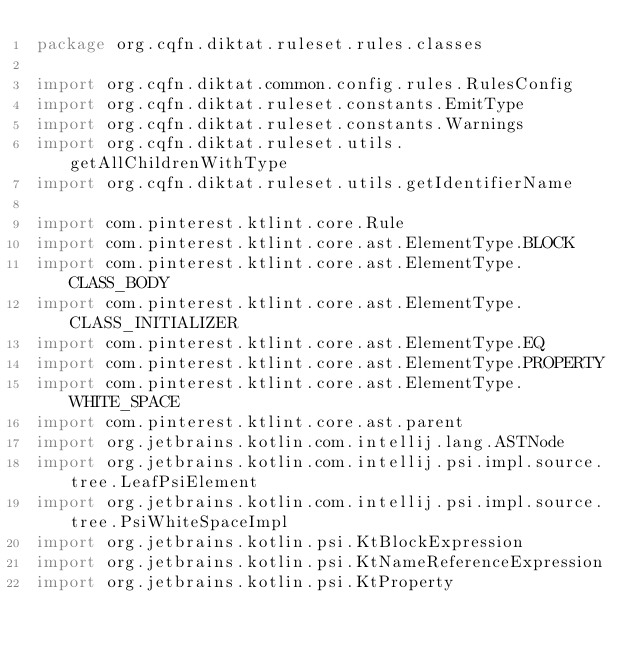Convert code to text. <code><loc_0><loc_0><loc_500><loc_500><_Kotlin_>package org.cqfn.diktat.ruleset.rules.classes

import org.cqfn.diktat.common.config.rules.RulesConfig
import org.cqfn.diktat.ruleset.constants.EmitType
import org.cqfn.diktat.ruleset.constants.Warnings
import org.cqfn.diktat.ruleset.utils.getAllChildrenWithType
import org.cqfn.diktat.ruleset.utils.getIdentifierName

import com.pinterest.ktlint.core.Rule
import com.pinterest.ktlint.core.ast.ElementType.BLOCK
import com.pinterest.ktlint.core.ast.ElementType.CLASS_BODY
import com.pinterest.ktlint.core.ast.ElementType.CLASS_INITIALIZER
import com.pinterest.ktlint.core.ast.ElementType.EQ
import com.pinterest.ktlint.core.ast.ElementType.PROPERTY
import com.pinterest.ktlint.core.ast.ElementType.WHITE_SPACE
import com.pinterest.ktlint.core.ast.parent
import org.jetbrains.kotlin.com.intellij.lang.ASTNode
import org.jetbrains.kotlin.com.intellij.psi.impl.source.tree.LeafPsiElement
import org.jetbrains.kotlin.com.intellij.psi.impl.source.tree.PsiWhiteSpaceImpl
import org.jetbrains.kotlin.psi.KtBlockExpression
import org.jetbrains.kotlin.psi.KtNameReferenceExpression
import org.jetbrains.kotlin.psi.KtProperty</code> 